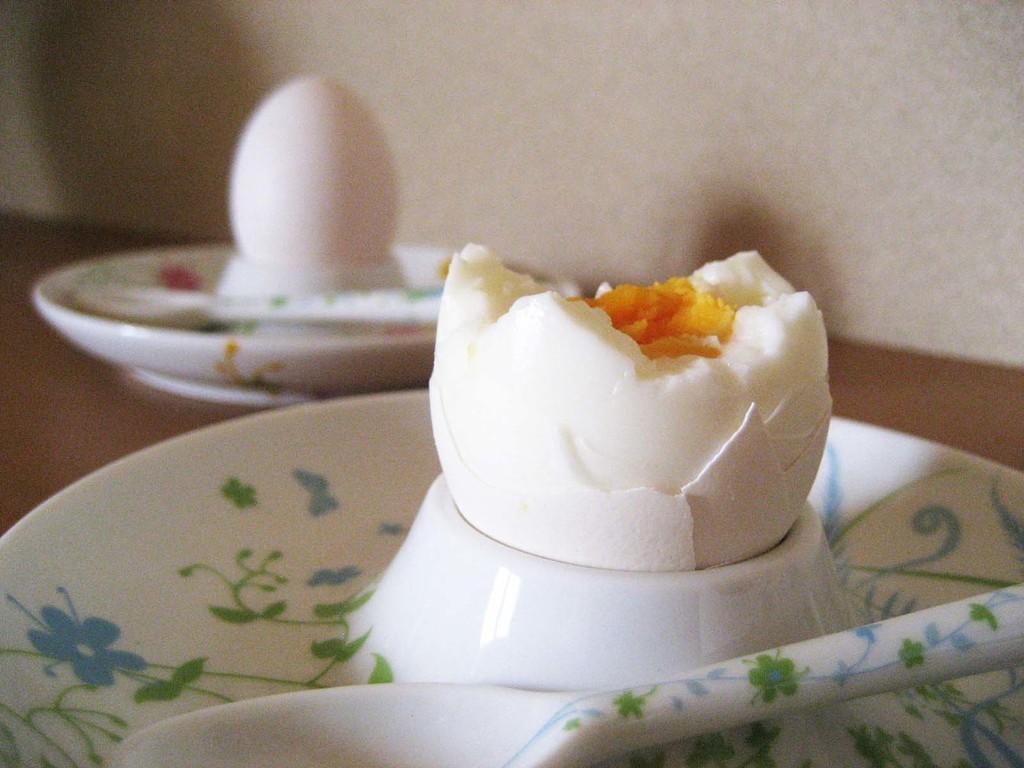How would you summarize this image in a sentence or two? In this picture we can see eggs and spoons in the plates. 